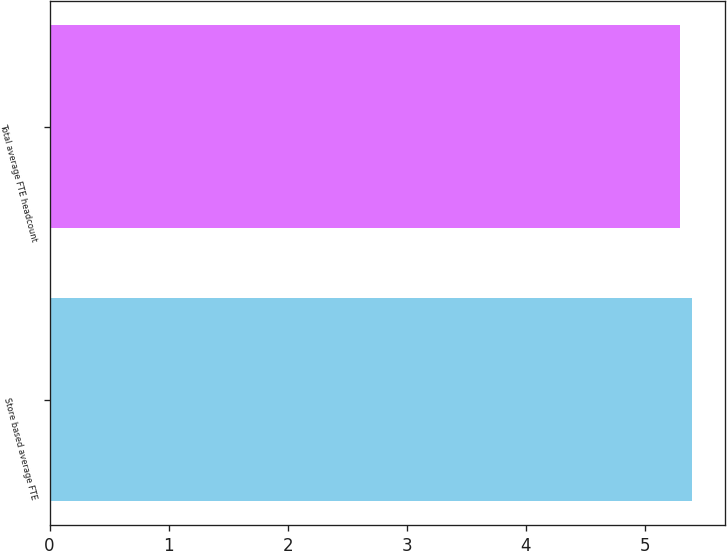Convert chart. <chart><loc_0><loc_0><loc_500><loc_500><bar_chart><fcel>Store based average FTE<fcel>Total average FTE headcount<nl><fcel>5.4<fcel>5.3<nl></chart> 